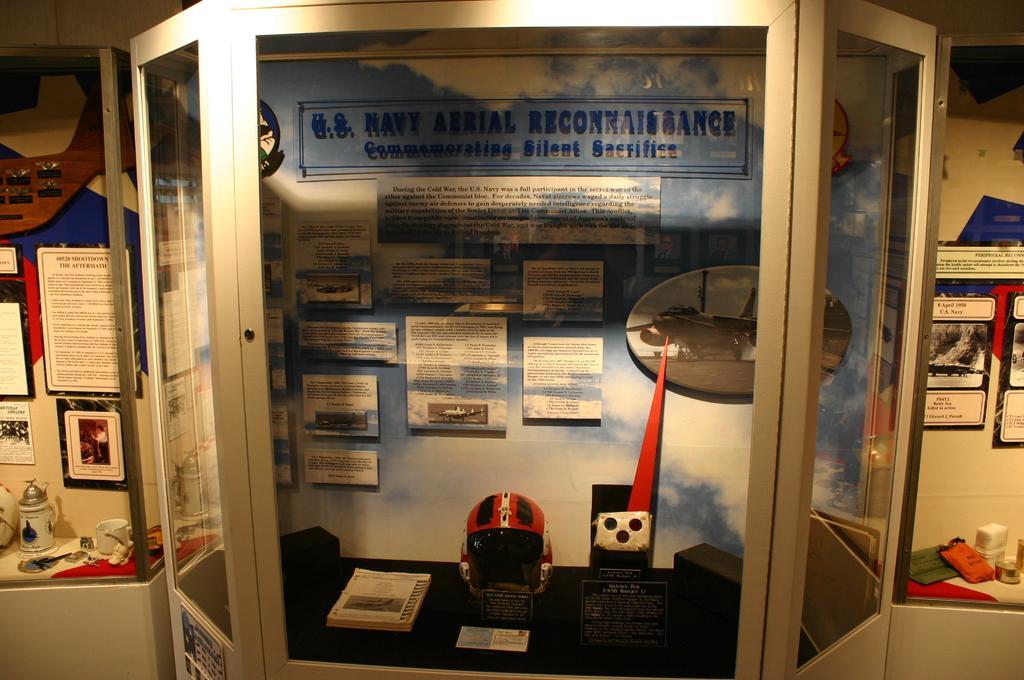Please provide a concise description of this image. In this image I can see the helmet, book and some boards on the black color surface. There is a paper to the wall. To the left I can see the some boards to the wall and there is a cup and some objects can be seen. To the right I can also see some boards to the wall and there are objects on the table. 